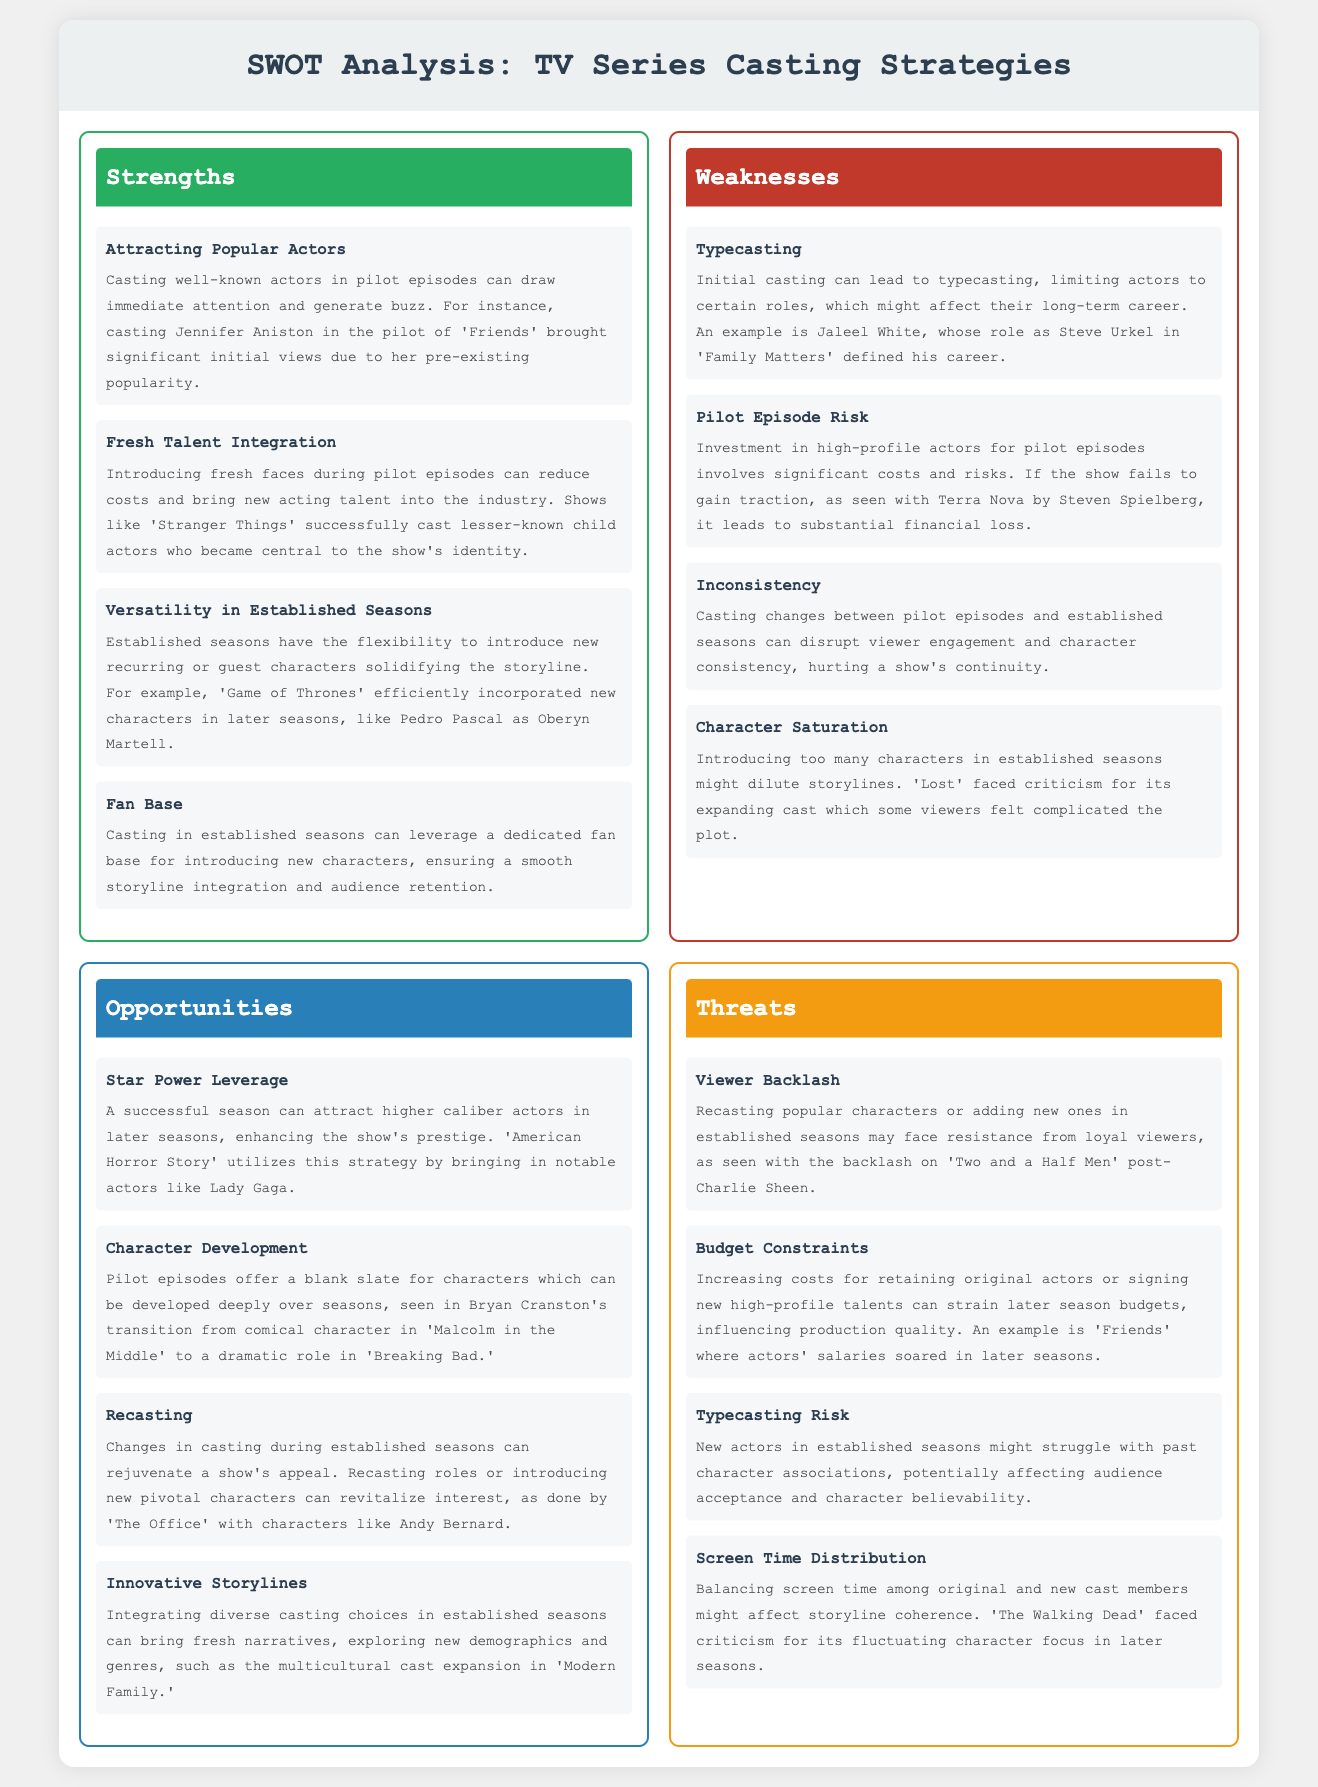What is one strength of casting well-known actors in pilot episodes? The strength is that it can draw immediate attention and generate buzz.
Answer: Attracting Popular Actors What is a weakness associated with initial casting? A common weakness is typecasting, which limits actors to certain roles.
Answer: Typecasting What opportunity allows for the development of characters over seasons? The opportunity is that pilot episodes offer a blank slate for characters to be developed deeply over seasons.
Answer: Character Development What is a threat that involves viewer response to cast changes? Viewer backlash is a threat that can arise from recasting popular characters or adding new ones.
Answer: Viewer Backlash In which TV series did casting a lesser-known actor enhance the show's identity? 'Stranger Things' successfully cast lesser-known child actors who became central to the show's identity.
Answer: Stranger Things What aspect can affect budget constraints in later seasons? Increasing costs for retaining original actors or signing new high-profile talents can strain later season budgets.
Answer: Budget Constraints What specific character introduction strategy is used in established seasons? The strategy is to introduce new recurring or guest characters to solidify the storyline.
Answer: Versatility in Established Seasons How can casting in established seasons leverage audience engagement? It can ensure a smooth storyline integration and audience retention by leveraging a dedicated fan base.
Answer: Fan Base 